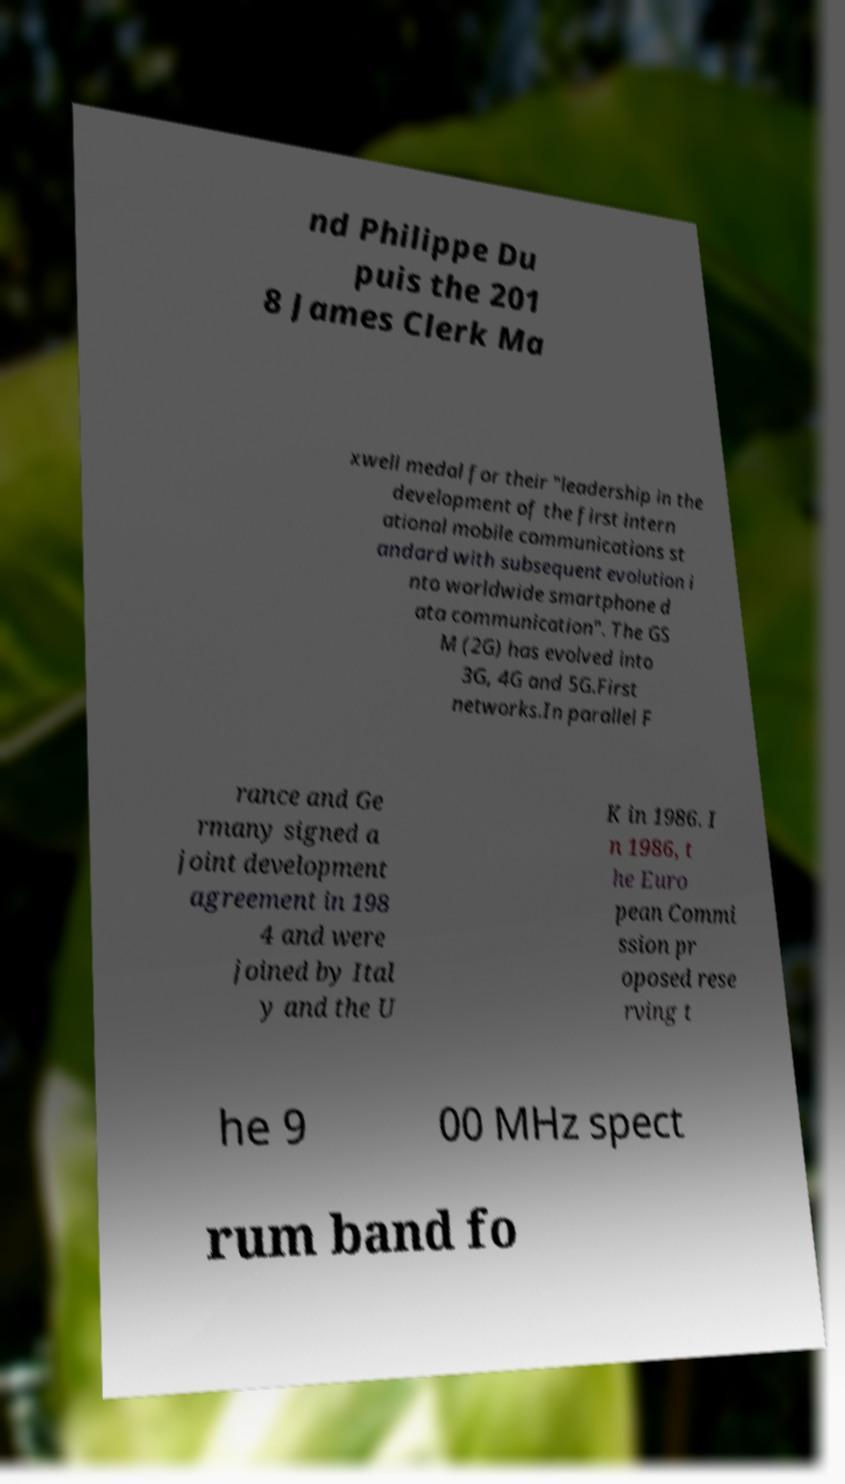Please identify and transcribe the text found in this image. nd Philippe Du puis the 201 8 James Clerk Ma xwell medal for their "leadership in the development of the first intern ational mobile communications st andard with subsequent evolution i nto worldwide smartphone d ata communication". The GS M (2G) has evolved into 3G, 4G and 5G.First networks.In parallel F rance and Ge rmany signed a joint development agreement in 198 4 and were joined by Ital y and the U K in 1986. I n 1986, t he Euro pean Commi ssion pr oposed rese rving t he 9 00 MHz spect rum band fo 